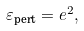Convert formula to latex. <formula><loc_0><loc_0><loc_500><loc_500>\varepsilon _ { \text {pert} } = e ^ { 2 } ,</formula> 